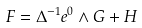<formula> <loc_0><loc_0><loc_500><loc_500>F = \Delta ^ { - 1 } e ^ { 0 } \wedge G + H</formula> 